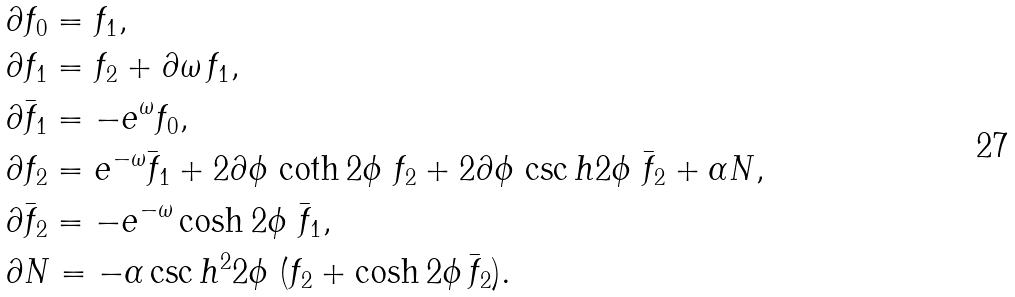<formula> <loc_0><loc_0><loc_500><loc_500>& \partial f _ { 0 } = f _ { 1 } , \\ & \partial f _ { 1 } = f _ { 2 } + \partial \omega \, f _ { 1 } , \\ & \partial \bar { f } _ { 1 } = - e ^ { \omega } f _ { 0 } , \\ & \partial f _ { 2 } = e ^ { - \omega } \bar { f } _ { 1 } + 2 \partial \phi \, \coth 2 \phi \ f _ { 2 } + 2 \partial \phi \, \csc h 2 \phi \ \bar { f } _ { 2 } + \alpha N , \\ & \partial \bar { f } _ { 2 } = - e ^ { - \omega } \cosh 2 \phi \ \bar { f } _ { 1 } , \\ & \partial N = - \alpha \csc h ^ { 2 } 2 \phi \ ( f _ { 2 } + \cosh 2 \phi \, \bar { f } _ { 2 } ) .</formula> 